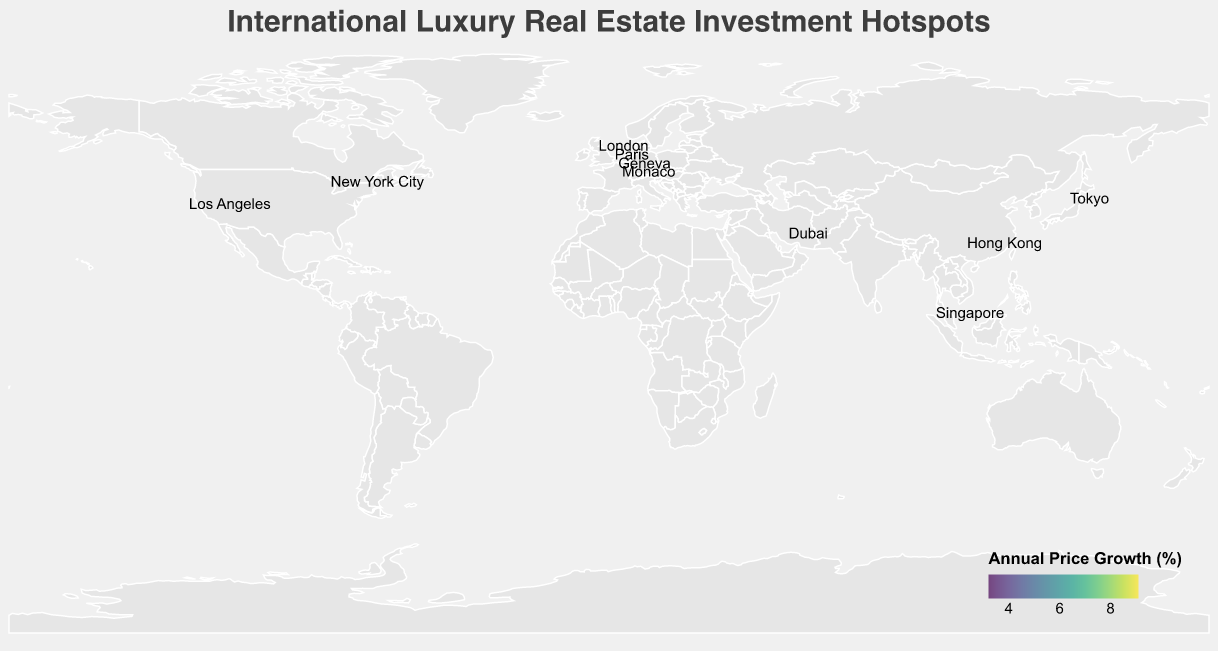What is the most expensive city for luxury properties? The city with the highest "Luxury Property Price (USD Millions)" is Monaco, with a price of 45.5 million USD.
Answer: Monaco Which city on the map has the highest annual price growth percentage? By looking at the "Annual Price Growth (%)" field, Dubai has the highest percentage at 9.1%.
Answer: Dubai How would you compare the average luxury property price in the United States to the average in Europe (United Kingdom, Monaco, Switzerland, and France)? First, calculate the average for the United States: (38.7 + 25.6)/2 = 32.15 million USD. Then, calculate the average for Europe: (42.3 + 45.5 + 33.8 + 29.4)/4 = 37.75 million USD. Monaco, although a city-state, counts here. The average price in Europe is higher.
Answer: Europe has a higher average price Which two cities have the closest luxury property prices? Compare the luxury property prices and find that Los Angeles (25.6 million USD) and Singapore (27.9 million USD) are the closest. The difference is 27.9 - 25.6 = 2.3 million USD.
Answer: Los Angeles and Singapore What type of property is most represented among the top five cities by luxury property price? Check the property types for the top five cities by luxury property price: Monaco (Penthouse), London (Mansion), New York City (Townhouse), Hong Kong (Luxury Apartment), and Geneva (Villa). Each type appears once.
Answer: No dominant type Looking at the geographic distribution, which continent has the most luxury real estate investment hotspots? By counting the number of cities per continent from the plot: Europe has Monaco, London, Geneva, Paris. Asia has Hong Kong, Dubai, Singapore, Tokyo. North America has New York City, Los Angeles. Europe and Asia each have four cities.
Answer: Europe and Asia tie What city in the United States shows a higher annual price growth for luxury properties? Comparing the two cities in the United States: New York City has 4.8%, and Los Angeles has 6.3%. Los Angeles has a higher annual price growth.
Answer: Los Angeles Which city has the lowest luxury property price, and what type of property is it? Tokyo has the lowest luxury property price at 23.8 million USD, and the property type is Luxury Condo.
Answer: Tokyo, Luxury Condo Compare the annual price growth percentage between Geneva and Paris. Which has higher growth? Geneva has an annual price growth of 6.7%, while Paris has 4.5%. Geneva has higher growth.
Answer: Geneva What's the next most expensive city after Monaco in terms of luxury property price? The next most expensive city after Monaco (45.5 million USD) is London, with a price of 42.3 million USD.
Answer: London 